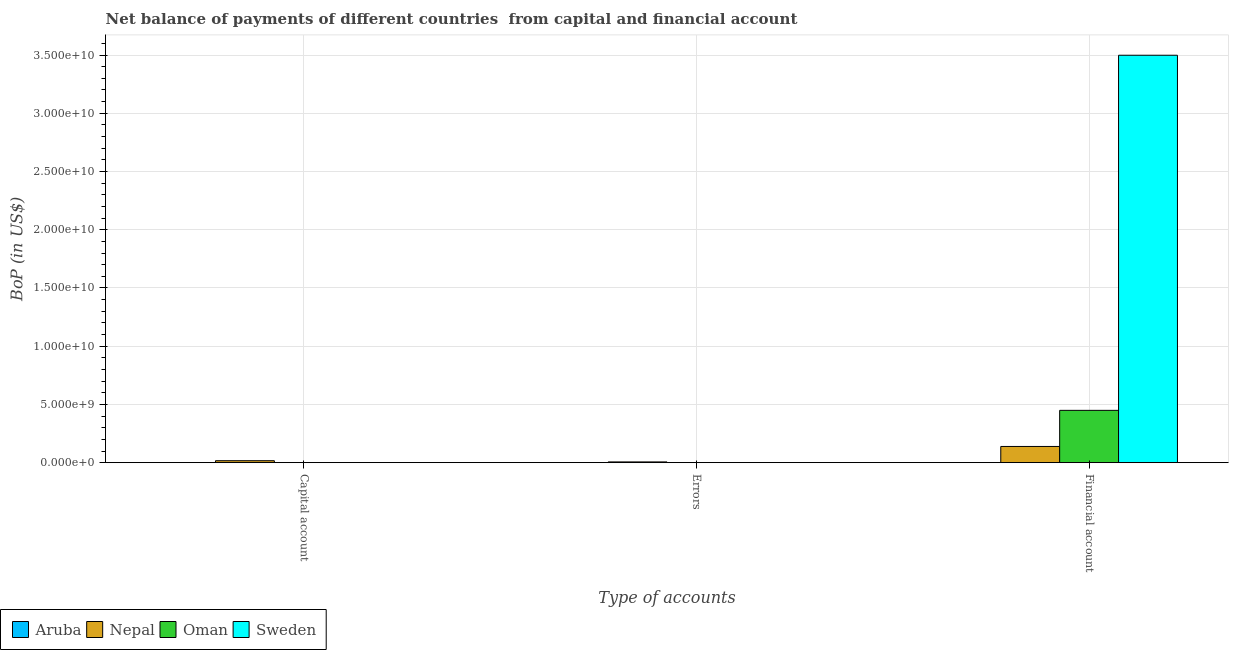How many different coloured bars are there?
Give a very brief answer. 4. Are the number of bars on each tick of the X-axis equal?
Offer a terse response. No. How many bars are there on the 3rd tick from the left?
Offer a terse response. 3. How many bars are there on the 3rd tick from the right?
Give a very brief answer. 2. What is the label of the 1st group of bars from the left?
Ensure brevity in your answer.  Capital account. What is the amount of errors in Aruba?
Your answer should be very brief. 0. Across all countries, what is the maximum amount of errors?
Provide a succinct answer. 6.31e+07. Across all countries, what is the minimum amount of errors?
Your answer should be compact. 0. In which country was the amount of net capital account maximum?
Keep it short and to the point. Nepal. What is the total amount of financial account in the graph?
Offer a terse response. 4.09e+1. What is the difference between the amount of financial account in Nepal and that in Sweden?
Provide a short and direct response. -3.36e+1. What is the difference between the amount of errors in Aruba and the amount of net capital account in Nepal?
Your answer should be very brief. -1.67e+08. What is the average amount of errors per country?
Ensure brevity in your answer.  1.58e+07. What is the difference between the amount of net capital account and amount of errors in Nepal?
Give a very brief answer. 1.04e+08. What is the ratio of the amount of financial account in Sweden to that in Oman?
Keep it short and to the point. 7.79. What is the difference between the highest and the lowest amount of net capital account?
Ensure brevity in your answer.  1.67e+08. Is the sum of the amount of net capital account in Aruba and Nepal greater than the maximum amount of errors across all countries?
Offer a terse response. Yes. Is it the case that in every country, the sum of the amount of net capital account and amount of errors is greater than the amount of financial account?
Keep it short and to the point. No. How many bars are there?
Ensure brevity in your answer.  6. Are all the bars in the graph horizontal?
Ensure brevity in your answer.  No. How many countries are there in the graph?
Give a very brief answer. 4. What is the difference between two consecutive major ticks on the Y-axis?
Ensure brevity in your answer.  5.00e+09. Are the values on the major ticks of Y-axis written in scientific E-notation?
Offer a terse response. Yes. Does the graph contain any zero values?
Give a very brief answer. Yes. Does the graph contain grids?
Make the answer very short. Yes. Where does the legend appear in the graph?
Provide a succinct answer. Bottom left. What is the title of the graph?
Your response must be concise. Net balance of payments of different countries  from capital and financial account. Does "Denmark" appear as one of the legend labels in the graph?
Offer a terse response. No. What is the label or title of the X-axis?
Your answer should be compact. Type of accounts. What is the label or title of the Y-axis?
Ensure brevity in your answer.  BoP (in US$). What is the BoP (in US$) of Aruba in Capital account?
Your response must be concise. 3.02e+06. What is the BoP (in US$) in Nepal in Capital account?
Make the answer very short. 1.67e+08. What is the BoP (in US$) in Aruba in Errors?
Keep it short and to the point. 0. What is the BoP (in US$) of Nepal in Errors?
Keep it short and to the point. 6.31e+07. What is the BoP (in US$) in Sweden in Errors?
Offer a very short reply. 0. What is the BoP (in US$) of Aruba in Financial account?
Provide a short and direct response. 0. What is the BoP (in US$) of Nepal in Financial account?
Keep it short and to the point. 1.39e+09. What is the BoP (in US$) in Oman in Financial account?
Offer a very short reply. 4.49e+09. What is the BoP (in US$) of Sweden in Financial account?
Provide a short and direct response. 3.50e+1. Across all Type of accounts, what is the maximum BoP (in US$) of Aruba?
Make the answer very short. 3.02e+06. Across all Type of accounts, what is the maximum BoP (in US$) in Nepal?
Make the answer very short. 1.39e+09. Across all Type of accounts, what is the maximum BoP (in US$) in Oman?
Keep it short and to the point. 4.49e+09. Across all Type of accounts, what is the maximum BoP (in US$) of Sweden?
Provide a succinct answer. 3.50e+1. Across all Type of accounts, what is the minimum BoP (in US$) of Aruba?
Your response must be concise. 0. Across all Type of accounts, what is the minimum BoP (in US$) of Nepal?
Provide a succinct answer. 6.31e+07. Across all Type of accounts, what is the minimum BoP (in US$) in Oman?
Your answer should be very brief. 0. Across all Type of accounts, what is the minimum BoP (in US$) in Sweden?
Give a very brief answer. 0. What is the total BoP (in US$) of Aruba in the graph?
Keep it short and to the point. 3.02e+06. What is the total BoP (in US$) in Nepal in the graph?
Ensure brevity in your answer.  1.62e+09. What is the total BoP (in US$) of Oman in the graph?
Your answer should be compact. 4.49e+09. What is the total BoP (in US$) of Sweden in the graph?
Provide a succinct answer. 3.50e+1. What is the difference between the BoP (in US$) in Nepal in Capital account and that in Errors?
Give a very brief answer. 1.04e+08. What is the difference between the BoP (in US$) of Nepal in Capital account and that in Financial account?
Offer a terse response. -1.22e+09. What is the difference between the BoP (in US$) in Nepal in Errors and that in Financial account?
Offer a terse response. -1.33e+09. What is the difference between the BoP (in US$) in Aruba in Capital account and the BoP (in US$) in Nepal in Errors?
Your response must be concise. -6.01e+07. What is the difference between the BoP (in US$) of Aruba in Capital account and the BoP (in US$) of Nepal in Financial account?
Your answer should be compact. -1.39e+09. What is the difference between the BoP (in US$) of Aruba in Capital account and the BoP (in US$) of Oman in Financial account?
Ensure brevity in your answer.  -4.49e+09. What is the difference between the BoP (in US$) of Aruba in Capital account and the BoP (in US$) of Sweden in Financial account?
Give a very brief answer. -3.50e+1. What is the difference between the BoP (in US$) in Nepal in Capital account and the BoP (in US$) in Oman in Financial account?
Your response must be concise. -4.32e+09. What is the difference between the BoP (in US$) in Nepal in Capital account and the BoP (in US$) in Sweden in Financial account?
Ensure brevity in your answer.  -3.48e+1. What is the difference between the BoP (in US$) of Nepal in Errors and the BoP (in US$) of Oman in Financial account?
Provide a short and direct response. -4.43e+09. What is the difference between the BoP (in US$) of Nepal in Errors and the BoP (in US$) of Sweden in Financial account?
Provide a succinct answer. -3.49e+1. What is the average BoP (in US$) in Aruba per Type of accounts?
Keep it short and to the point. 1.01e+06. What is the average BoP (in US$) of Nepal per Type of accounts?
Offer a terse response. 5.40e+08. What is the average BoP (in US$) in Oman per Type of accounts?
Your answer should be very brief. 1.50e+09. What is the average BoP (in US$) of Sweden per Type of accounts?
Your answer should be very brief. 1.17e+1. What is the difference between the BoP (in US$) of Aruba and BoP (in US$) of Nepal in Capital account?
Provide a succinct answer. -1.64e+08. What is the difference between the BoP (in US$) in Nepal and BoP (in US$) in Oman in Financial account?
Keep it short and to the point. -3.10e+09. What is the difference between the BoP (in US$) in Nepal and BoP (in US$) in Sweden in Financial account?
Offer a very short reply. -3.36e+1. What is the difference between the BoP (in US$) in Oman and BoP (in US$) in Sweden in Financial account?
Provide a short and direct response. -3.05e+1. What is the ratio of the BoP (in US$) in Nepal in Capital account to that in Errors?
Keep it short and to the point. 2.65. What is the ratio of the BoP (in US$) of Nepal in Capital account to that in Financial account?
Offer a very short reply. 0.12. What is the ratio of the BoP (in US$) in Nepal in Errors to that in Financial account?
Offer a very short reply. 0.05. What is the difference between the highest and the second highest BoP (in US$) in Nepal?
Ensure brevity in your answer.  1.22e+09. What is the difference between the highest and the lowest BoP (in US$) in Aruba?
Make the answer very short. 3.02e+06. What is the difference between the highest and the lowest BoP (in US$) of Nepal?
Ensure brevity in your answer.  1.33e+09. What is the difference between the highest and the lowest BoP (in US$) in Oman?
Ensure brevity in your answer.  4.49e+09. What is the difference between the highest and the lowest BoP (in US$) of Sweden?
Give a very brief answer. 3.50e+1. 